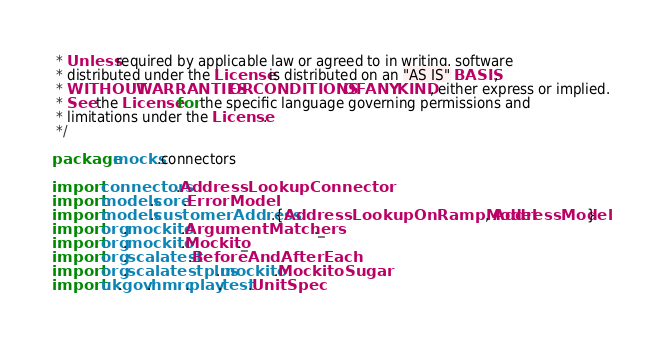Convert code to text. <code><loc_0><loc_0><loc_500><loc_500><_Scala_> * Unless required by applicable law or agreed to in writing, software
 * distributed under the License is distributed on an "AS IS" BASIS,
 * WITHOUT WARRANTIES OR CONDITIONS OF ANY KIND, either express or implied.
 * See the License for the specific language governing permissions and
 * limitations under the License.
 */

package mocks.connectors

import connectors.AddressLookupConnector
import models.core.ErrorModel
import models.customerAddress.{AddressLookupOnRampModel, AddressModel}
import org.mockito.ArgumentMatchers._
import org.mockito.Mockito._
import org.scalatest.BeforeAndAfterEach
import org.scalatestplus.mockito.MockitoSugar
import uk.gov.hmrc.play.test.UnitSpec
</code> 